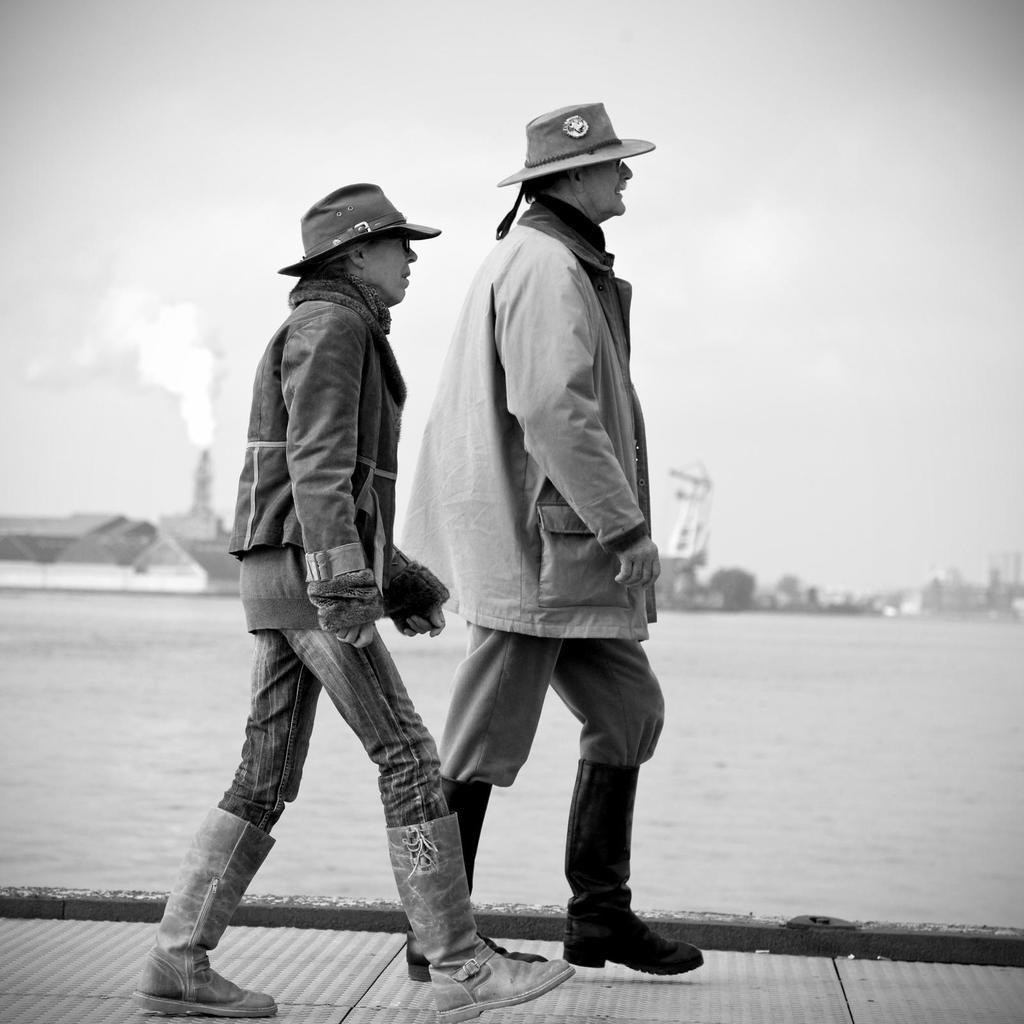How many people are in the image? There are two people in the image. What are the people wearing? The people are wearing clothes, hats, and shoes. What are the people doing in the image? The people are walking. What surface are the people walking on in the image? There is a footpath in the image. What can be seen in the background of the image? Water, a boat, smoke, and the sky are visible in the image. What type of ornament is hanging from the boat in the image? There is no ornament hanging from the boat in the image. What rhythm is the boat following as it moves through the water? The boat is not moving in the image, so there is no rhythm to describe. 